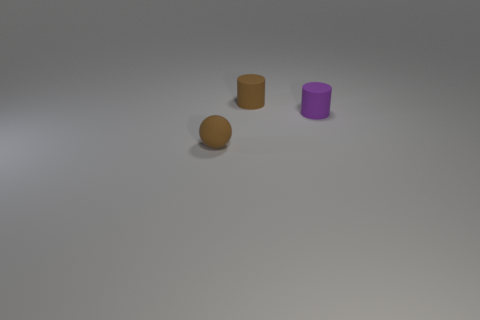There is a sphere; does it have the same color as the matte cylinder behind the purple cylinder?
Provide a succinct answer. Yes. Is there a thing that has the same color as the small rubber ball?
Provide a succinct answer. Yes. The small rubber thing that is the same color as the small sphere is what shape?
Offer a terse response. Cylinder. What number of things are either red cylinders or things that are right of the brown ball?
Offer a very short reply. 2. What number of other matte things have the same shape as the tiny purple thing?
Offer a very short reply. 1. There is a tiny purple thing that is made of the same material as the brown ball; what is its shape?
Keep it short and to the point. Cylinder. There is a purple matte object; is its size the same as the object in front of the tiny purple thing?
Keep it short and to the point. Yes. What is the material of the brown object that is the same shape as the purple thing?
Provide a succinct answer. Rubber. Does the brown rubber ball have the same size as the purple cylinder?
Keep it short and to the point. Yes. Do the brown object that is behind the small sphere and the thing that is to the right of the tiny brown cylinder have the same shape?
Make the answer very short. Yes. 